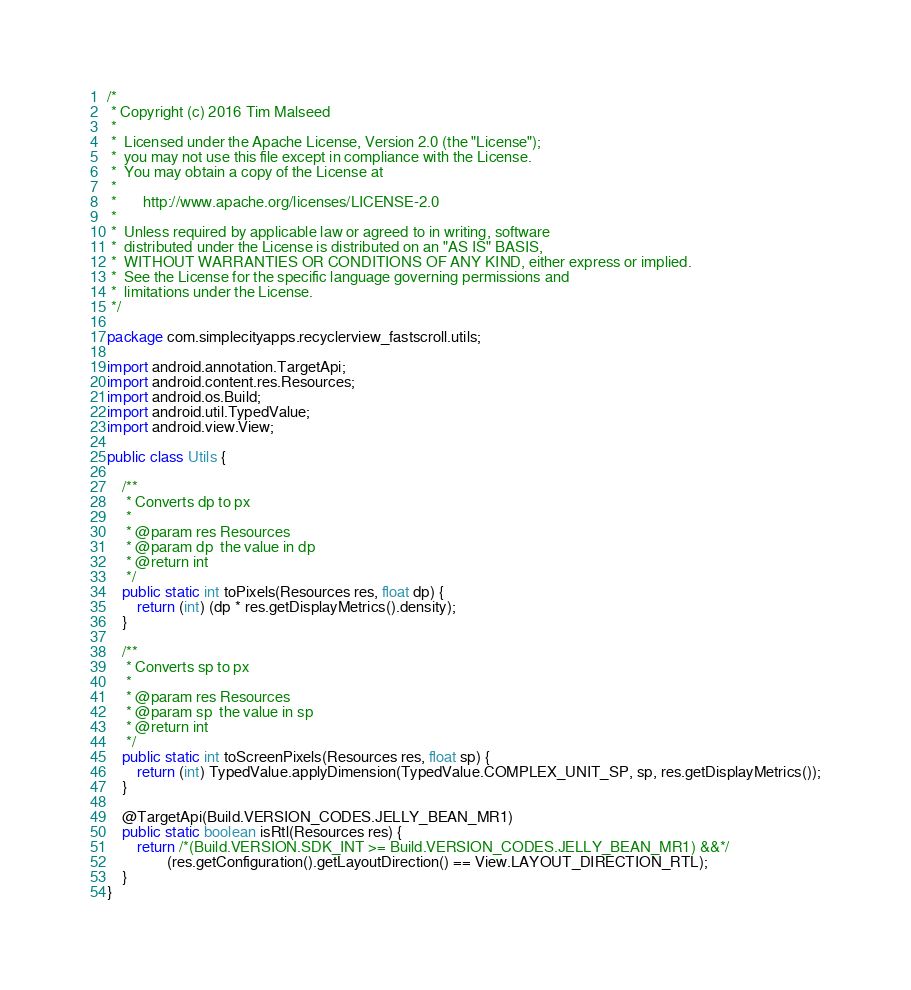<code> <loc_0><loc_0><loc_500><loc_500><_Java_>/*
 * Copyright (c) 2016 Tim Malseed
 *
 *  Licensed under the Apache License, Version 2.0 (the "License");
 *  you may not use this file except in compliance with the License.
 *  You may obtain a copy of the License at
 *
 *       http://www.apache.org/licenses/LICENSE-2.0
 *
 *  Unless required by applicable law or agreed to in writing, software
 *  distributed under the License is distributed on an "AS IS" BASIS,
 *  WITHOUT WARRANTIES OR CONDITIONS OF ANY KIND, either express or implied.
 *  See the License for the specific language governing permissions and
 *  limitations under the License.
 */

package com.simplecityapps.recyclerview_fastscroll.utils;

import android.annotation.TargetApi;
import android.content.res.Resources;
import android.os.Build;
import android.util.TypedValue;
import android.view.View;

public class Utils {

    /**
     * Converts dp to px
     *
     * @param res Resources
     * @param dp  the value in dp
     * @return int
     */
    public static int toPixels(Resources res, float dp) {
        return (int) (dp * res.getDisplayMetrics().density);
    }

    /**
     * Converts sp to px
     *
     * @param res Resources
     * @param sp  the value in sp
     * @return int
     */
    public static int toScreenPixels(Resources res, float sp) {
        return (int) TypedValue.applyDimension(TypedValue.COMPLEX_UNIT_SP, sp, res.getDisplayMetrics());
    }

    @TargetApi(Build.VERSION_CODES.JELLY_BEAN_MR1)
    public static boolean isRtl(Resources res) {
        return /*(Build.VERSION.SDK_INT >= Build.VERSION_CODES.JELLY_BEAN_MR1) &&*/
                (res.getConfiguration().getLayoutDirection() == View.LAYOUT_DIRECTION_RTL);
    }
}
</code> 